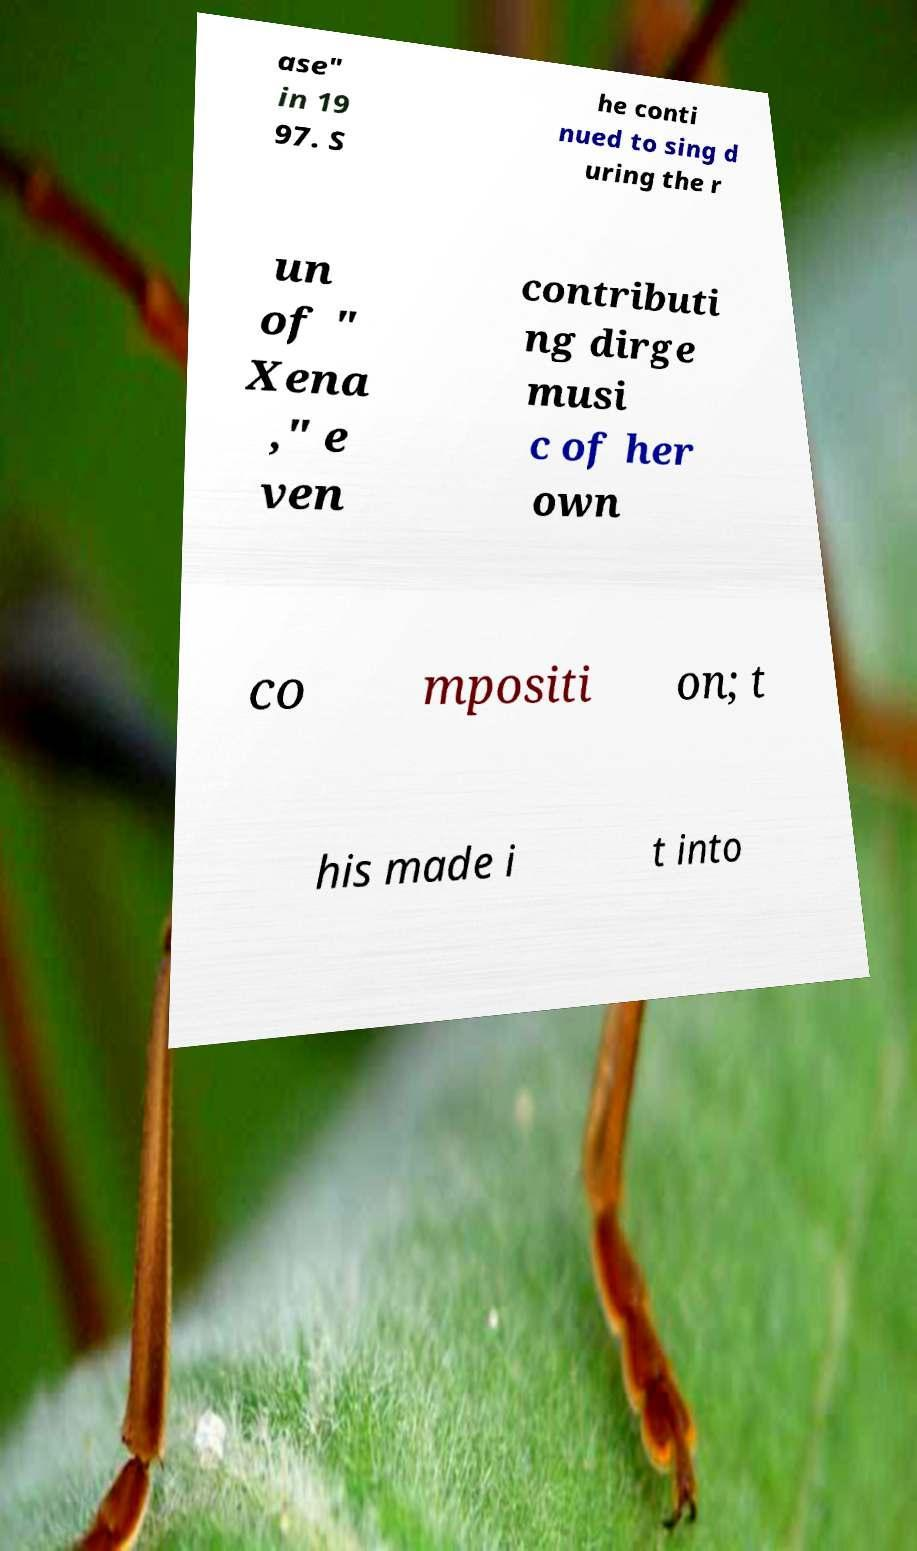There's text embedded in this image that I need extracted. Can you transcribe it verbatim? ase" in 19 97. S he conti nued to sing d uring the r un of " Xena ," e ven contributi ng dirge musi c of her own co mpositi on; t his made i t into 